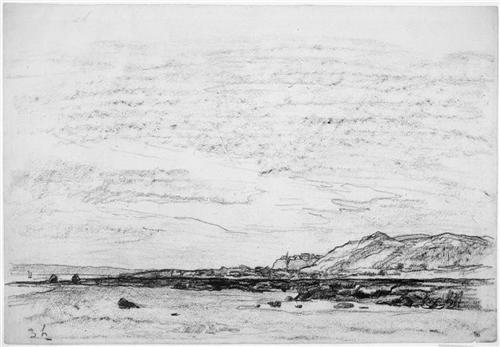What techniques might the artist have used to achieve the texture in this sketch? The artist likely employed a variety of pencil strokes to create the textures seen in the sketch. Techniques such as hatching and cross-hatching are evident, where lines are drawn close together and in crossing patterns to build up shades and textures. Additionally, stippling, using dots to create depth or texture, may have been used in certain areas to further define the rocks and clouds. 